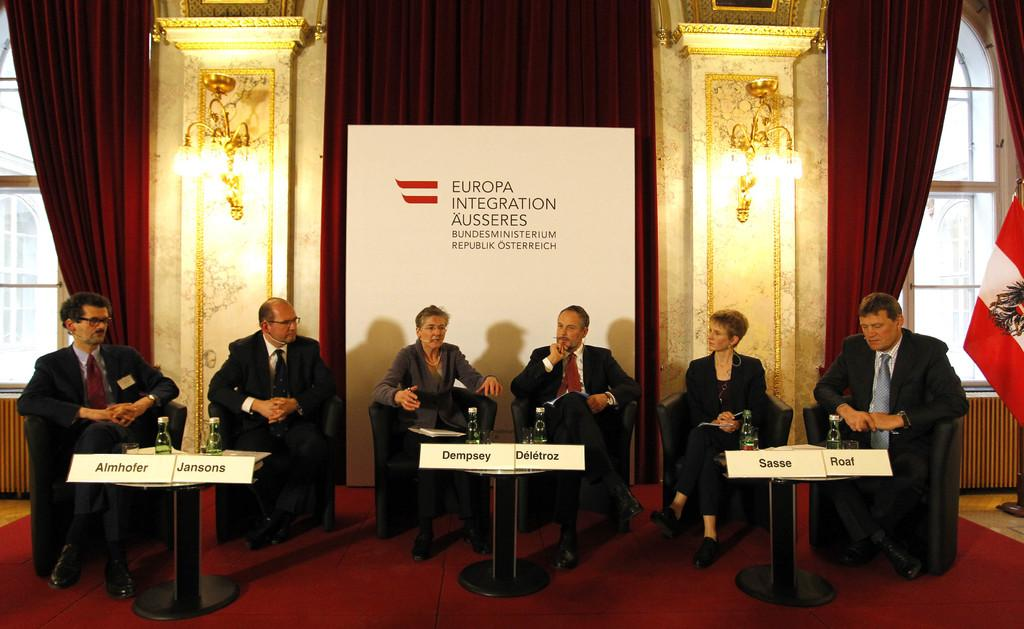What type of window treatment is visible in the image? There are curtains in the image. What can be used to provide illumination in the image? There are lights in the image. What type of decoration is present in the image? There is a banner in the image. What are the people in the image doing? There are people sitting on chairs in the image. What type of printed material is visible in the image? There is a poster in the image. What type of container is present in the image? There is a bottle in the image. What type of wrench is being used to fix the poster in the image? There is no wrench present in the image, and the poster does not appear to be in need of repair. What smell can be detected in the image? The image does not provide any information about smells, so it cannot be determined from the image. 